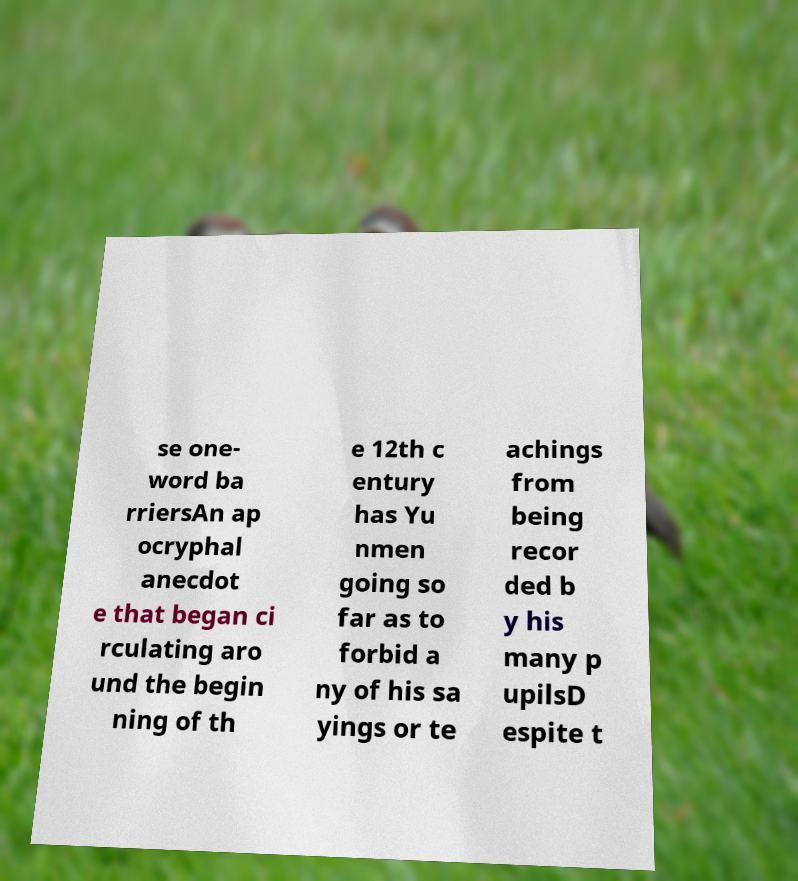Can you read and provide the text displayed in the image?This photo seems to have some interesting text. Can you extract and type it out for me? se one- word ba rriersAn ap ocryphal anecdot e that began ci rculating aro und the begin ning of th e 12th c entury has Yu nmen going so far as to forbid a ny of his sa yings or te achings from being recor ded b y his many p upilsD espite t 